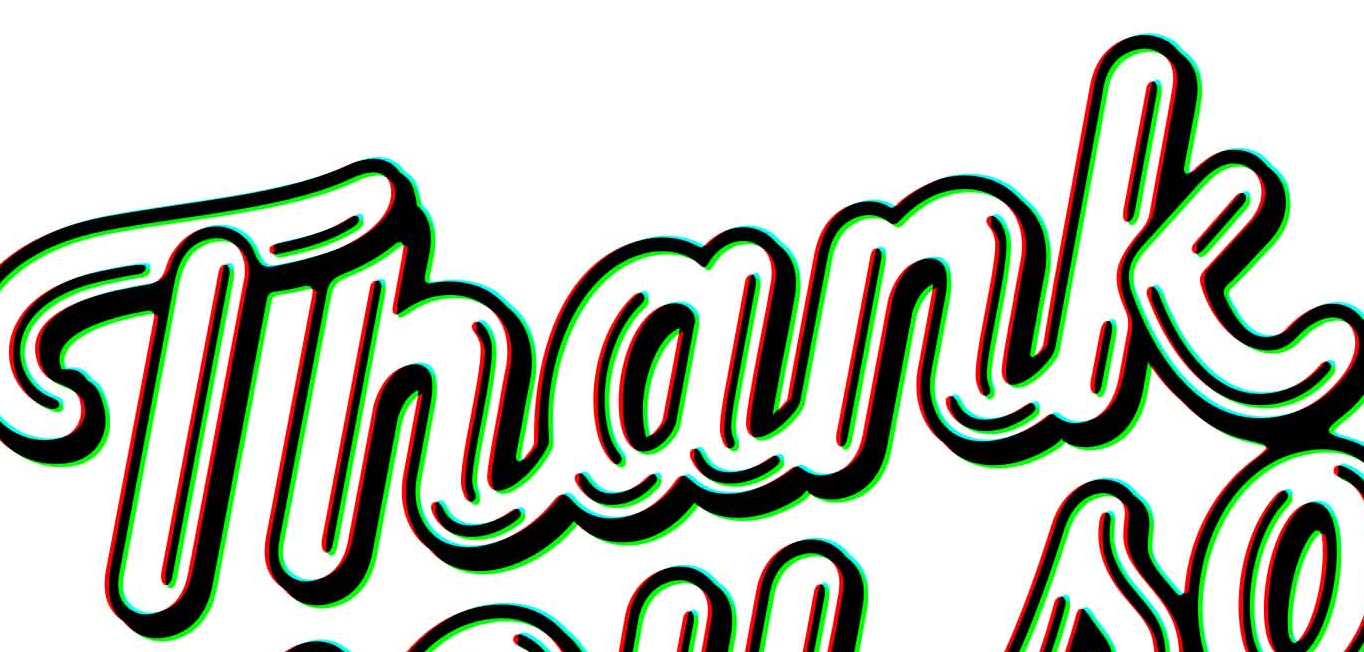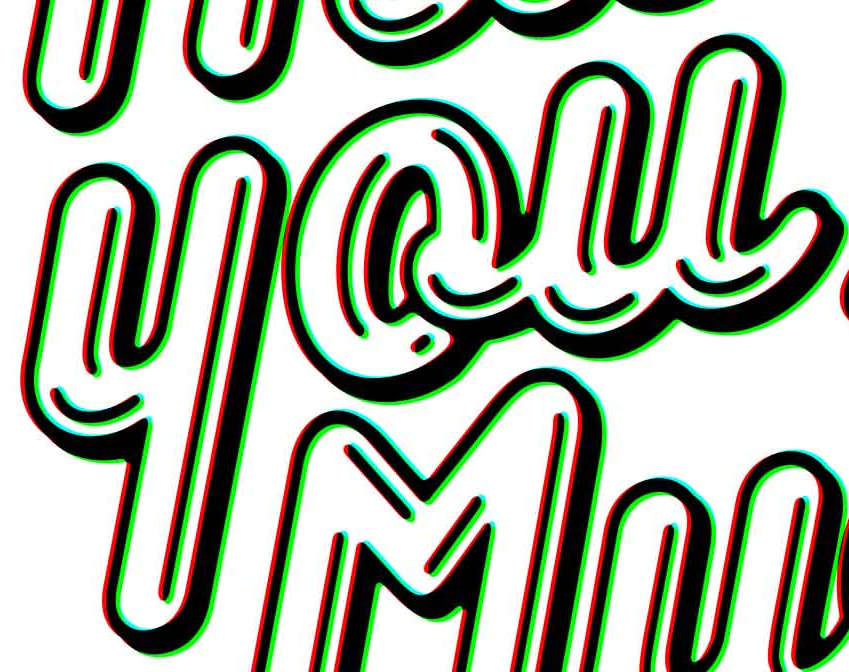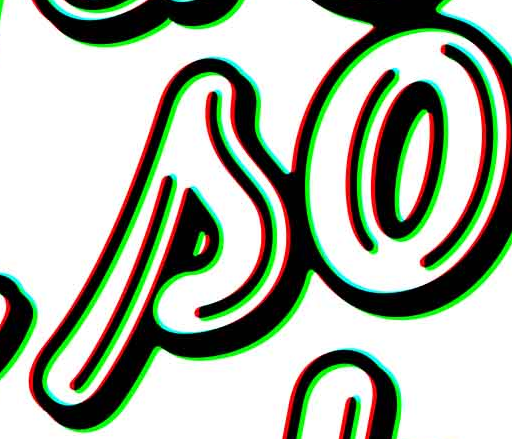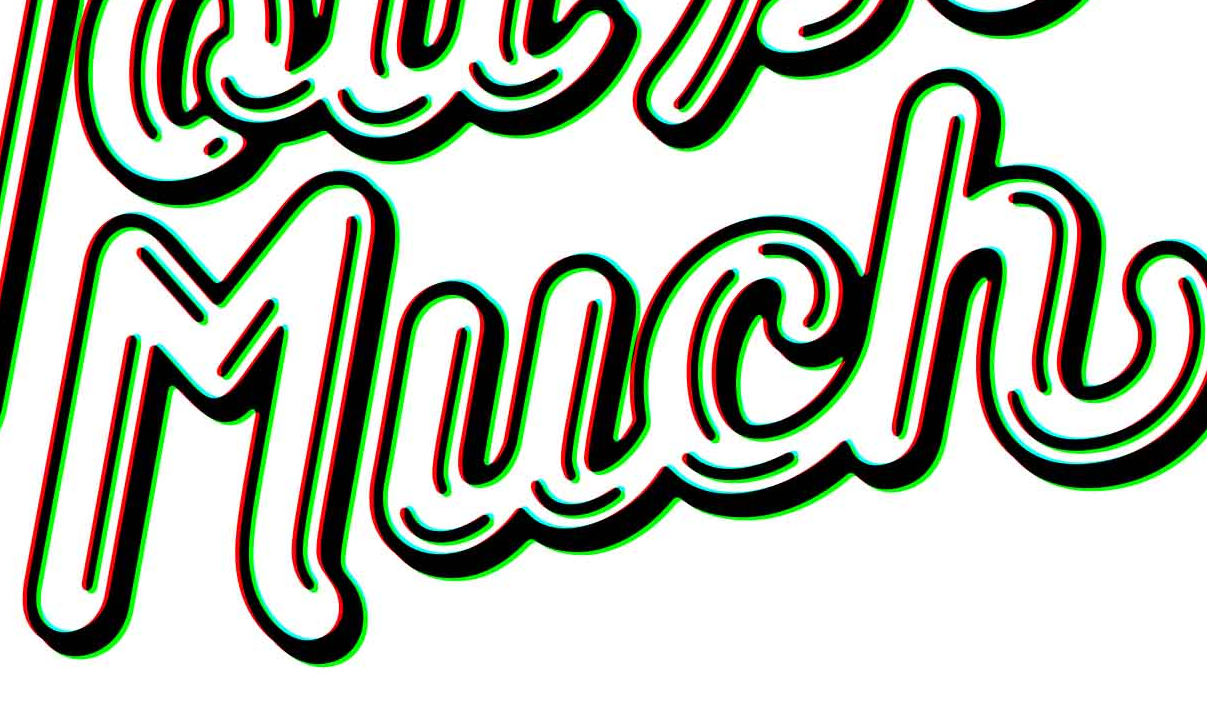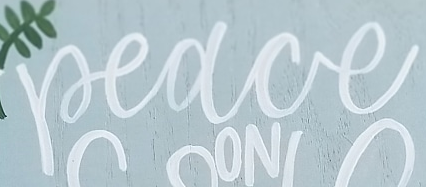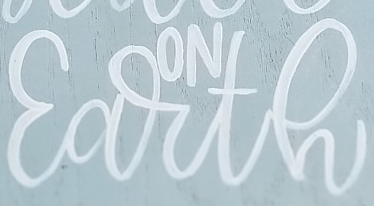Identify the words shown in these images in order, separated by a semicolon. Thank; you; so; Much; Peace; Earth 